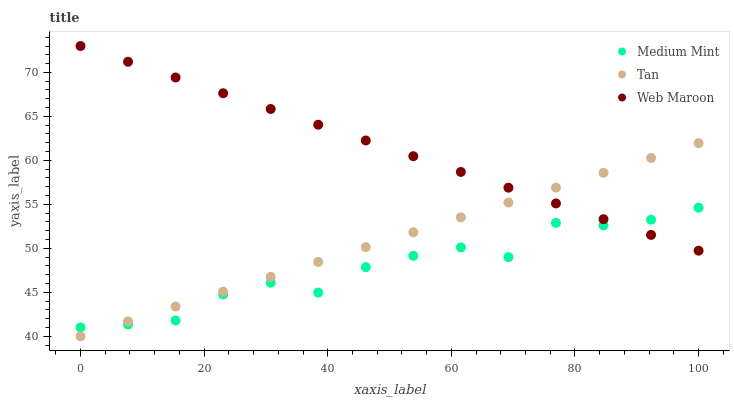Does Medium Mint have the minimum area under the curve?
Answer yes or no. Yes. Does Web Maroon have the maximum area under the curve?
Answer yes or no. Yes. Does Tan have the minimum area under the curve?
Answer yes or no. No. Does Tan have the maximum area under the curve?
Answer yes or no. No. Is Tan the smoothest?
Answer yes or no. Yes. Is Medium Mint the roughest?
Answer yes or no. Yes. Is Web Maroon the smoothest?
Answer yes or no. No. Is Web Maroon the roughest?
Answer yes or no. No. Does Tan have the lowest value?
Answer yes or no. Yes. Does Web Maroon have the lowest value?
Answer yes or no. No. Does Web Maroon have the highest value?
Answer yes or no. Yes. Does Tan have the highest value?
Answer yes or no. No. Does Tan intersect Web Maroon?
Answer yes or no. Yes. Is Tan less than Web Maroon?
Answer yes or no. No. Is Tan greater than Web Maroon?
Answer yes or no. No. 